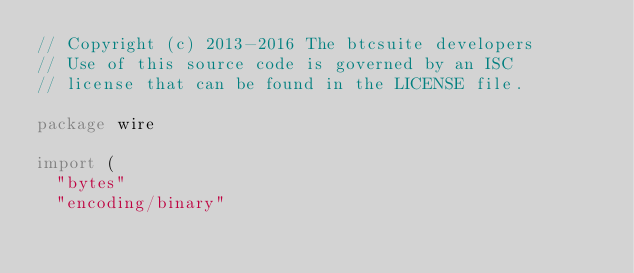Convert code to text. <code><loc_0><loc_0><loc_500><loc_500><_Go_>// Copyright (c) 2013-2016 The btcsuite developers
// Use of this source code is governed by an ISC
// license that can be found in the LICENSE file.

package wire

import (
	"bytes"
	"encoding/binary"</code> 